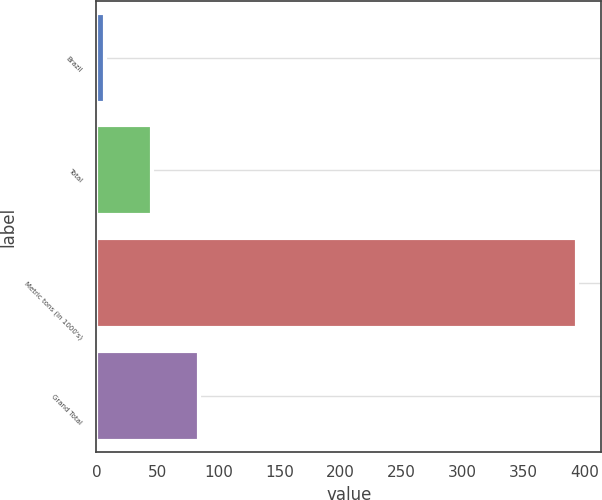Convert chart to OTSL. <chart><loc_0><loc_0><loc_500><loc_500><bar_chart><fcel>Brazil<fcel>Total<fcel>Metric tons (in 1000's)<fcel>Grand Total<nl><fcel>7<fcel>45.7<fcel>394<fcel>84.4<nl></chart> 